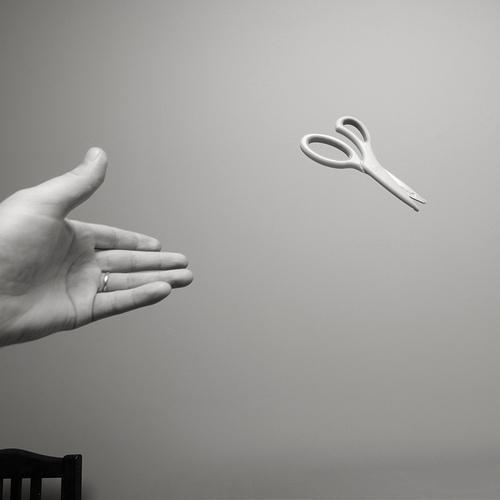How many objects are in the picture?
Give a very brief answer. 3. 